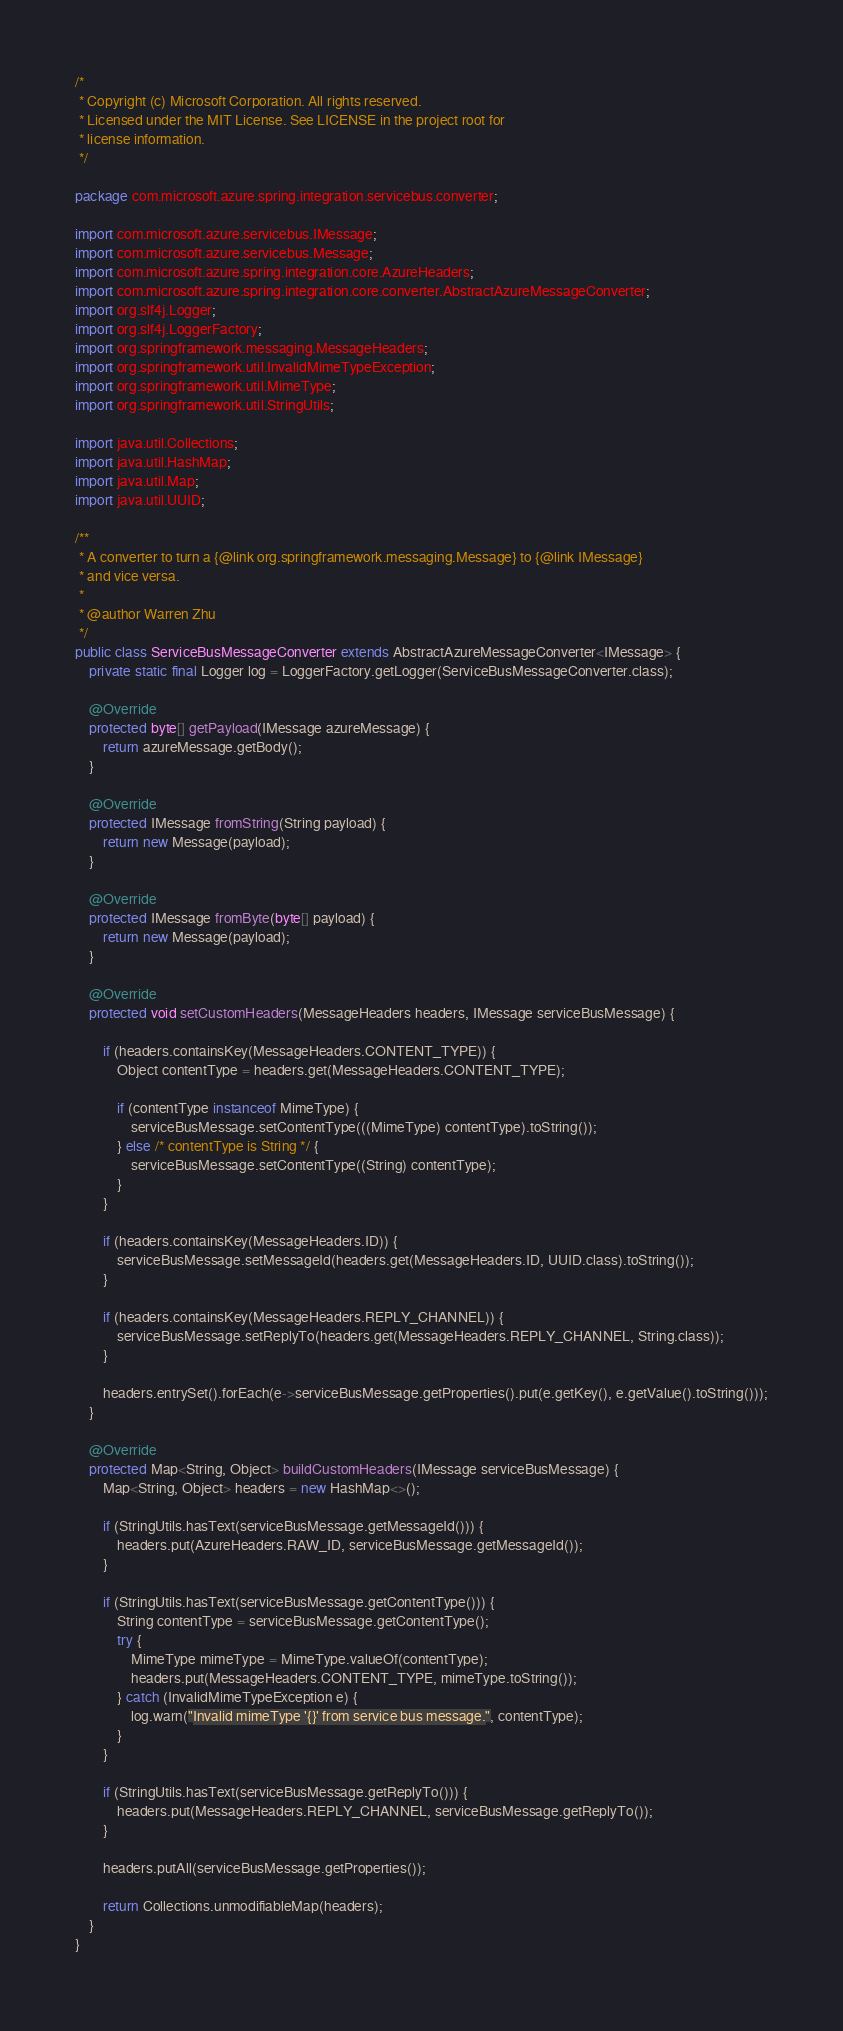<code> <loc_0><loc_0><loc_500><loc_500><_Java_>/*
 * Copyright (c) Microsoft Corporation. All rights reserved.
 * Licensed under the MIT License. See LICENSE in the project root for
 * license information.
 */

package com.microsoft.azure.spring.integration.servicebus.converter;

import com.microsoft.azure.servicebus.IMessage;
import com.microsoft.azure.servicebus.Message;
import com.microsoft.azure.spring.integration.core.AzureHeaders;
import com.microsoft.azure.spring.integration.core.converter.AbstractAzureMessageConverter;
import org.slf4j.Logger;
import org.slf4j.LoggerFactory;
import org.springframework.messaging.MessageHeaders;
import org.springframework.util.InvalidMimeTypeException;
import org.springframework.util.MimeType;
import org.springframework.util.StringUtils;

import java.util.Collections;
import java.util.HashMap;
import java.util.Map;
import java.util.UUID;

/**
 * A converter to turn a {@link org.springframework.messaging.Message} to {@link IMessage}
 * and vice versa.
 *
 * @author Warren Zhu
 */
public class ServiceBusMessageConverter extends AbstractAzureMessageConverter<IMessage> {
    private static final Logger log = LoggerFactory.getLogger(ServiceBusMessageConverter.class);

    @Override
    protected byte[] getPayload(IMessage azureMessage) {
        return azureMessage.getBody();
    }

    @Override
    protected IMessage fromString(String payload) {
        return new Message(payload);
    }

    @Override
    protected IMessage fromByte(byte[] payload) {
        return new Message(payload);
    }

    @Override
    protected void setCustomHeaders(MessageHeaders headers, IMessage serviceBusMessage) {

        if (headers.containsKey(MessageHeaders.CONTENT_TYPE)) {
            Object contentType = headers.get(MessageHeaders.CONTENT_TYPE);

            if (contentType instanceof MimeType) {
                serviceBusMessage.setContentType(((MimeType) contentType).toString());
            } else /* contentType is String */ {
                serviceBusMessage.setContentType((String) contentType);
            }
        }

        if (headers.containsKey(MessageHeaders.ID)) {
            serviceBusMessage.setMessageId(headers.get(MessageHeaders.ID, UUID.class).toString());
        }

        if (headers.containsKey(MessageHeaders.REPLY_CHANNEL)) {
            serviceBusMessage.setReplyTo(headers.get(MessageHeaders.REPLY_CHANNEL, String.class));
        }

        headers.entrySet().forEach(e->serviceBusMessage.getProperties().put(e.getKey(), e.getValue().toString()));
    }

    @Override
    protected Map<String, Object> buildCustomHeaders(IMessage serviceBusMessage) {
        Map<String, Object> headers = new HashMap<>();

        if (StringUtils.hasText(serviceBusMessage.getMessageId())) {
            headers.put(AzureHeaders.RAW_ID, serviceBusMessage.getMessageId());
        }

        if (StringUtils.hasText(serviceBusMessage.getContentType())) {
            String contentType = serviceBusMessage.getContentType();
            try {
                MimeType mimeType = MimeType.valueOf(contentType);
                headers.put(MessageHeaders.CONTENT_TYPE, mimeType.toString());
            } catch (InvalidMimeTypeException e) {
                log.warn("Invalid mimeType '{}' from service bus message.", contentType);
            }
        }

        if (StringUtils.hasText(serviceBusMessage.getReplyTo())) {
            headers.put(MessageHeaders.REPLY_CHANNEL, serviceBusMessage.getReplyTo());
        }

        headers.putAll(serviceBusMessage.getProperties());

        return Collections.unmodifiableMap(headers);
    }
}
</code> 